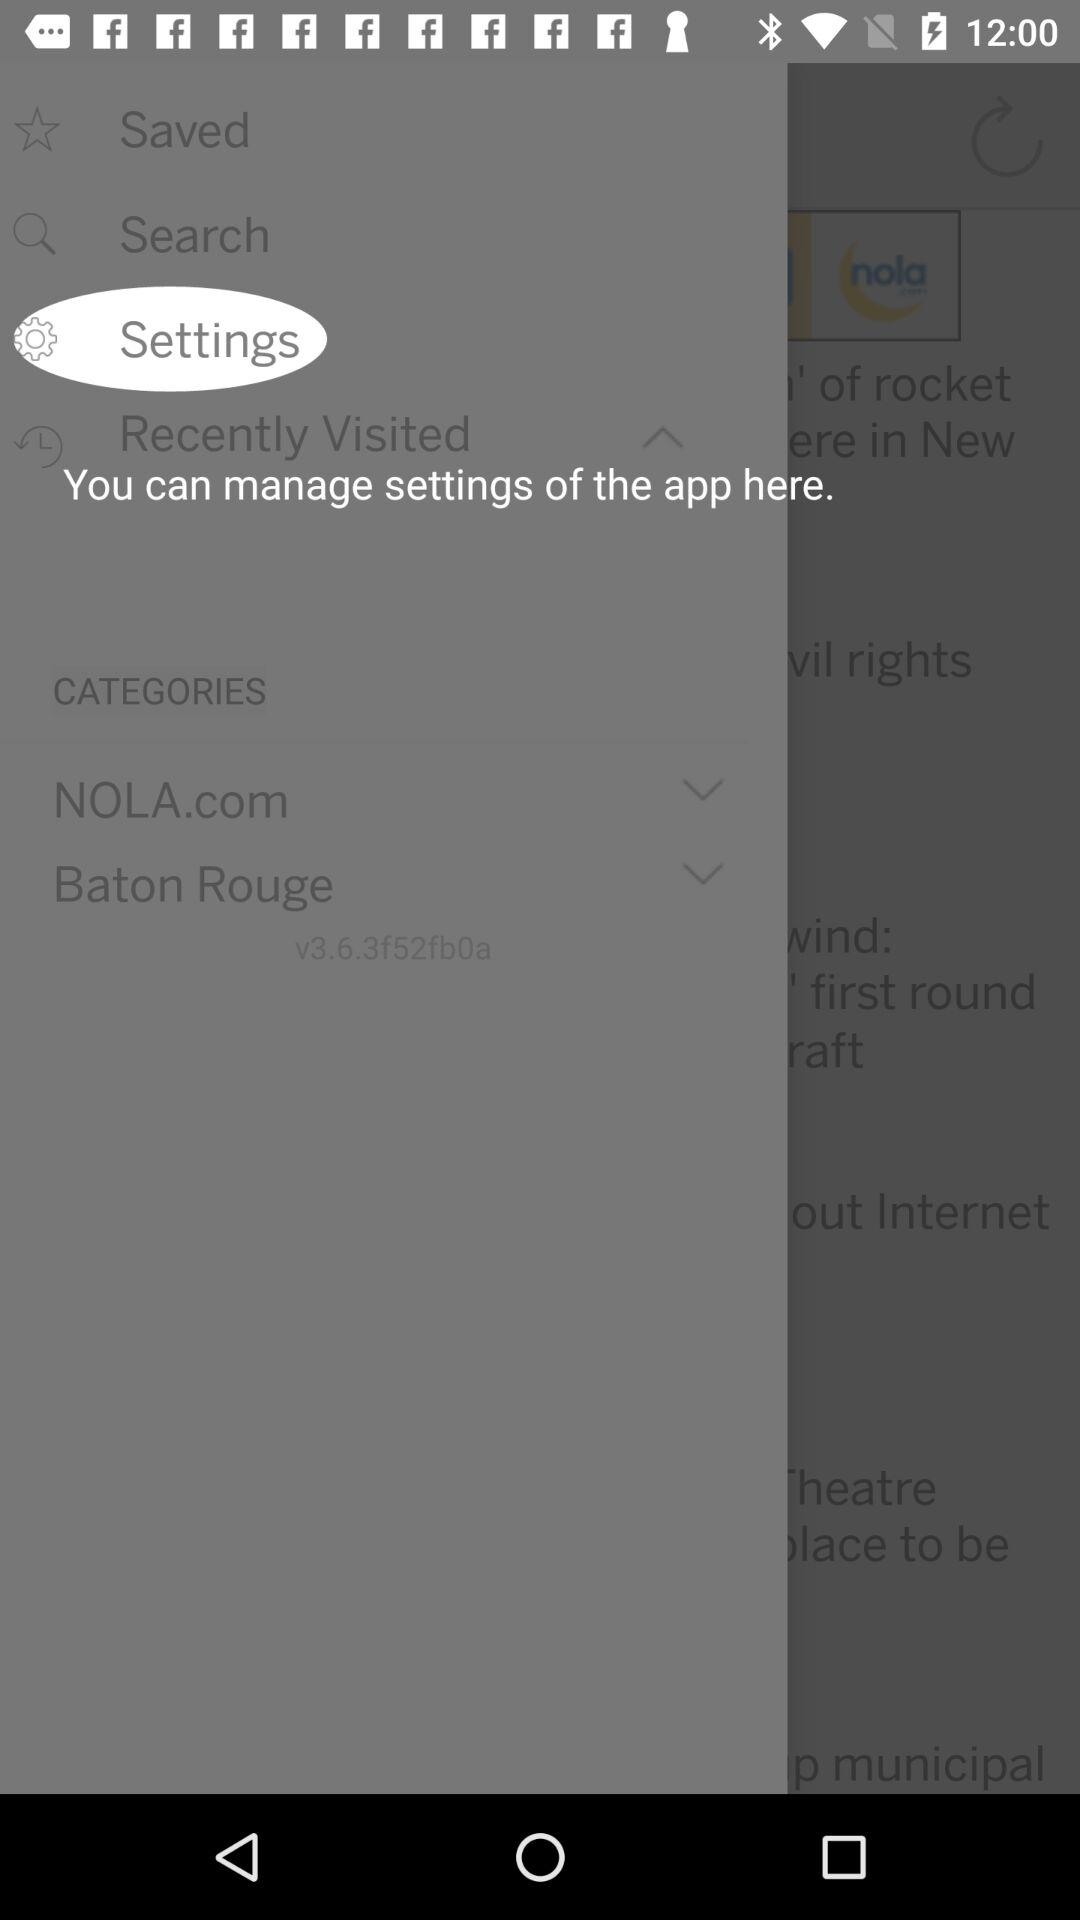What are the different types of categories? The different types of categories are "NOLA.com" and "Baton Rouge". 